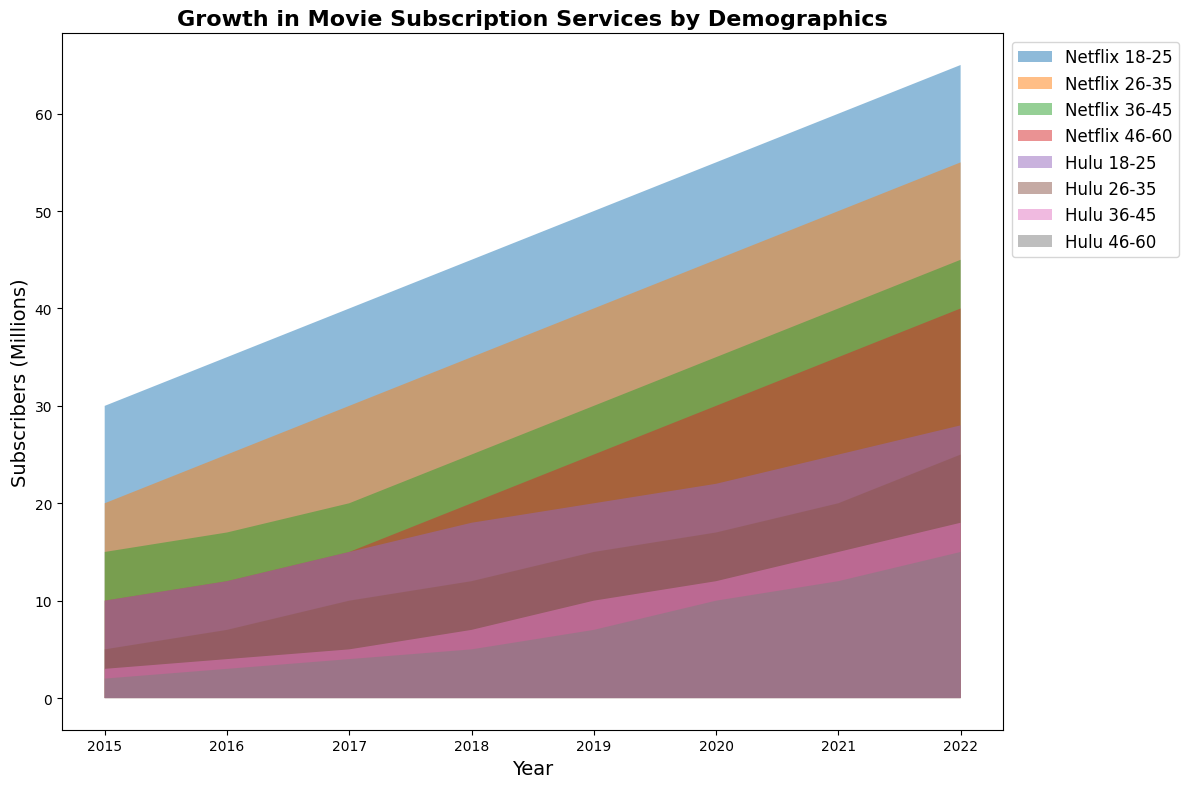How many more 18-25 subscribers did Netflix have in 2022 compared to 2015? Identify the number of 18-25 Netflix subscribers in both 2022 (65 million) and 2015 (30 million). Subtract the 2015 figure from the 2022 figure: 65 - 30 = 35.
Answer: 35 million What is the average number of Hulu subscribers in the 26-35 age group across all years? Sum the number of Hulu subscribers in the 26-35 age group for each year: 5 + 7 + 10 + 12 + 15 + 17 + 20 + 25 = 111. Divide this sum by the number of years (8): 111 ÷ 8 = 13.875.
Answer: 13.88 million Which service had more subscribers across all age groups in 2018, and what was the difference in total subscribers between the services? Sum the number of subscribers for each service: Netflix (45 + 35 + 25 + 20 = 125 million) and Hulu (18 + 12 + 7 + 5 = 42 million). Subtract the Hulu total from the Netflix total: 125 - 42 = 83.
Answer: Netflix, 83 million In which year did Hulu see the largest increase in 18-25 subscribers compared to the previous year, and what was the value of this increase? Calculate the year-to-year increase for Hulu 18-25 subscribers: 
2016-2015: 12 - 10 = 2 
2017-2016: 15 - 12 = 3 
2018-2017: 18 - 15 = 3 
2019-2018: 20 - 18 = 2 
2020-2019: 22 - 20 = 2 
2021-2020: 25 - 22 = 3 
2022-2021: 28 - 25 = 3 
The largest increase was 3 million, occurring in 2017, 2021, and 2022.
Answer: 2017, 3 million Compare the trends in subscribers for Netflix and Hulu for the 36-45 age group. Which service saw a higher growth rate, and how much did that group grow for each service? Calculate the growth for each service:
Netflix: 45 million (2022) - 15 million (2015) = 30 million 
Hulu: 18 million (2022) - 3 million (2015) = 15 million 
Netflix saw a higher growth rate with an increase of 30 million, while Hulu's increase was 15 million.
Answer: Netflix, 30 million Which age group contributed most to the subscriber growth for both Netflix and Hulu from 2015 to 2022? Calculate the growth for each age group for both services:
Netflix:
18-25: 65 - 30 = 35 million 
26-35: 55 - 20 = 35 million 
36-45: 45 - 15 = 30 million 
46-60: 40 - 10 = 30 million 
Hulu:
18-25: 28 - 10 = 18 million 
26-35: 25 - 5 = 20 million 
36-45: 18 - 3 = 15 million 
46-60: 15 - 2 = 13 million 
For Netflix, the highest growth is in both the 18-25 and 26-35 age groups (35 million). For Hulu, it's the 26-35 age group (20 million).
Answer: Netflix: 18-25 and 26-35 (35 million each); Hulu: 26-35 (20 million) 